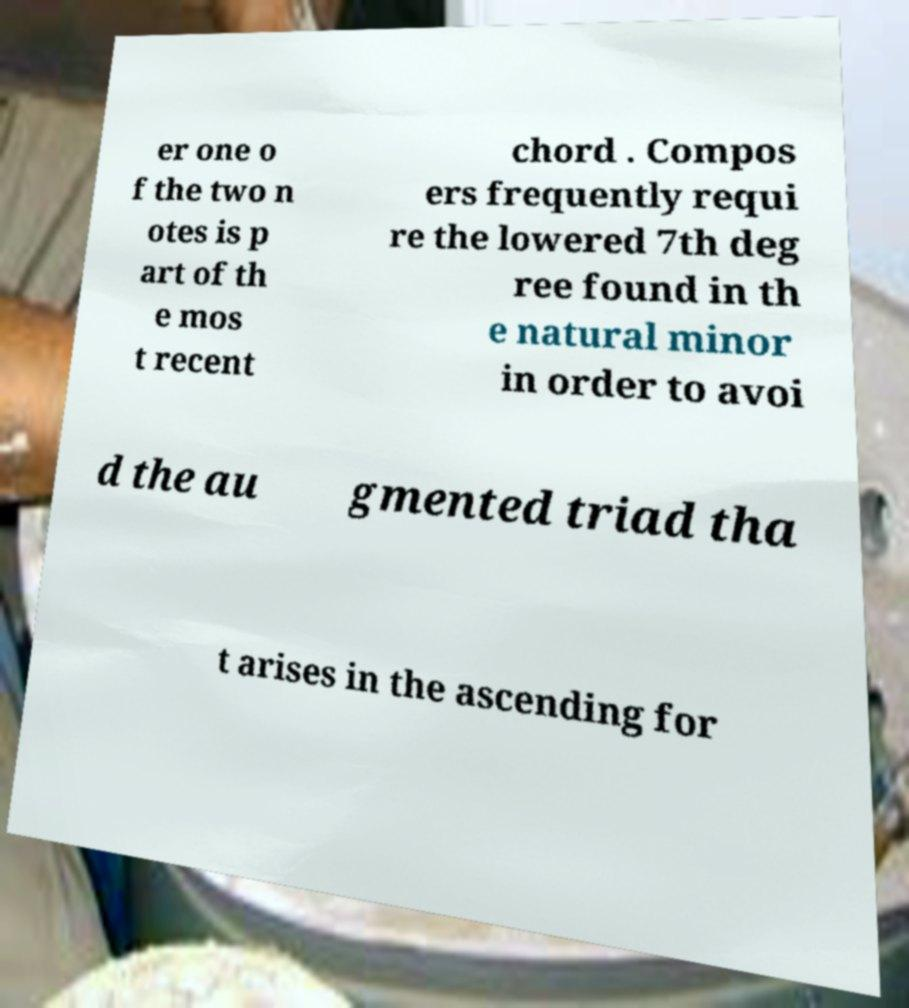Can you read and provide the text displayed in the image?This photo seems to have some interesting text. Can you extract and type it out for me? er one o f the two n otes is p art of th e mos t recent chord . Compos ers frequently requi re the lowered 7th deg ree found in th e natural minor in order to avoi d the au gmented triad tha t arises in the ascending for 